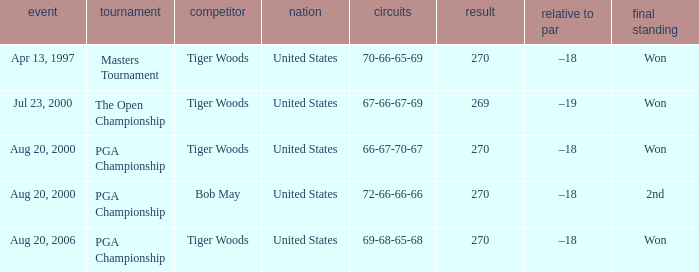What is the worst (highest) score? 270.0. 